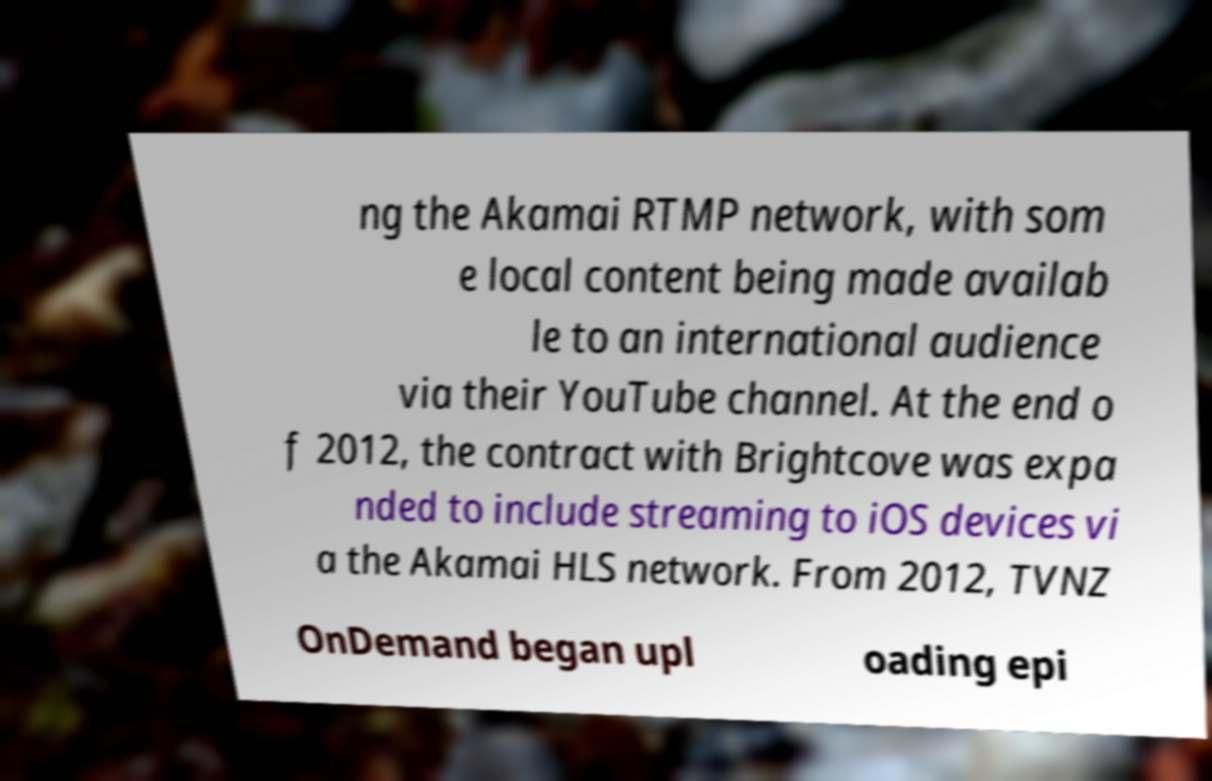Please identify and transcribe the text found in this image. ng the Akamai RTMP network, with som e local content being made availab le to an international audience via their YouTube channel. At the end o f 2012, the contract with Brightcove was expa nded to include streaming to iOS devices vi a the Akamai HLS network. From 2012, TVNZ OnDemand began upl oading epi 